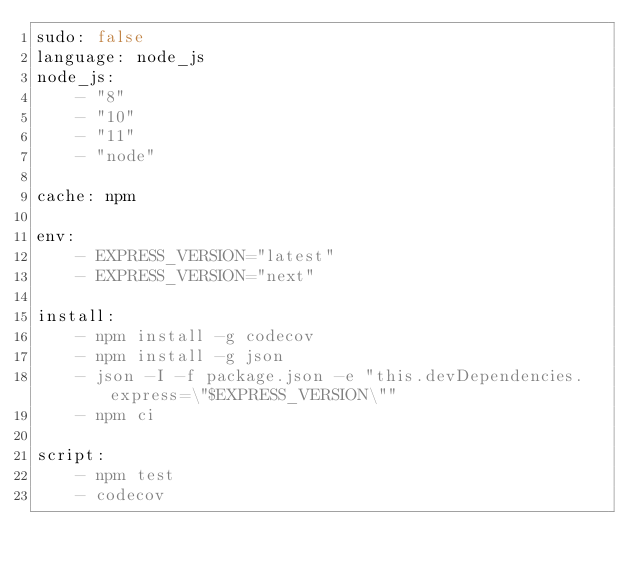<code> <loc_0><loc_0><loc_500><loc_500><_YAML_>sudo: false
language: node_js
node_js:
    - "8"
    - "10"
    - "11"
    - "node"

cache: npm

env:
    - EXPRESS_VERSION="latest"
    - EXPRESS_VERSION="next"

install:
    - npm install -g codecov
    - npm install -g json
    - json -I -f package.json -e "this.devDependencies.express=\"$EXPRESS_VERSION\""
    - npm ci

script:
    - npm test
    - codecov

</code> 